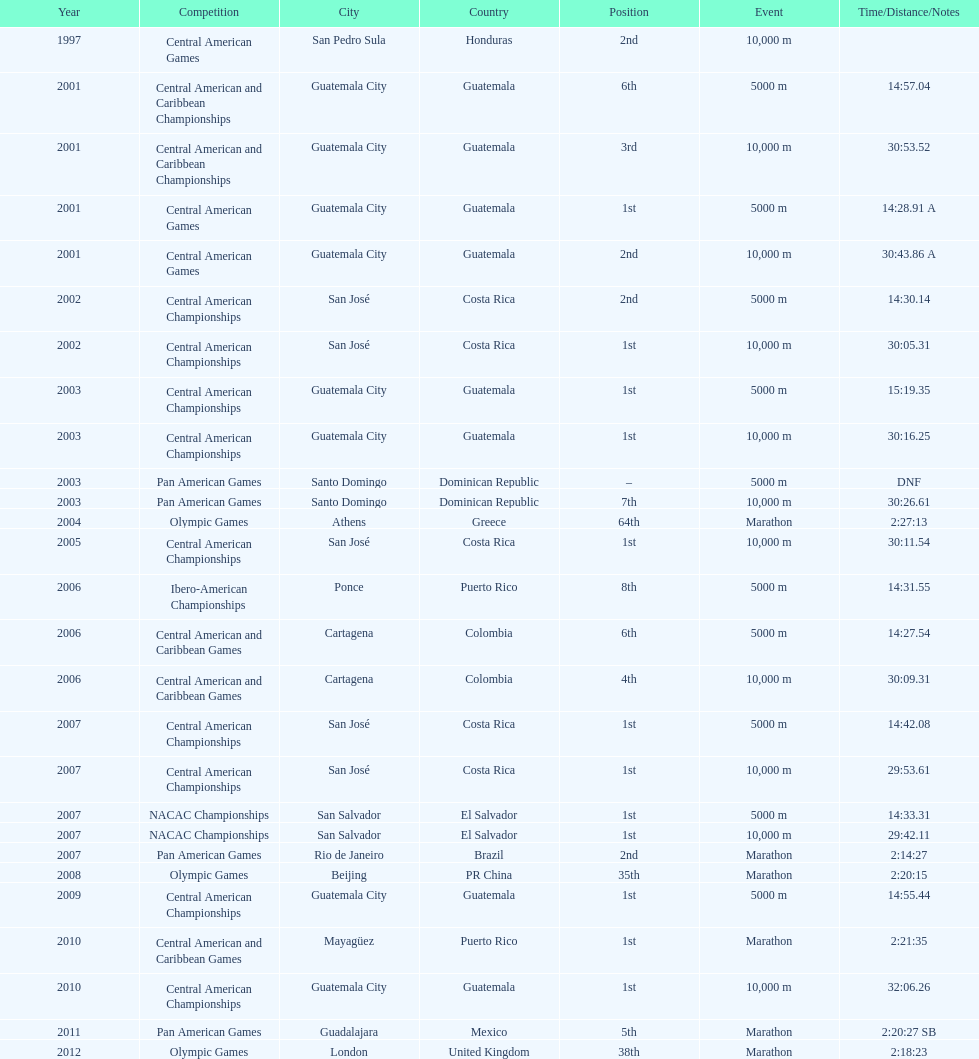What was the first competition this competitor competed in? Central American Games. 